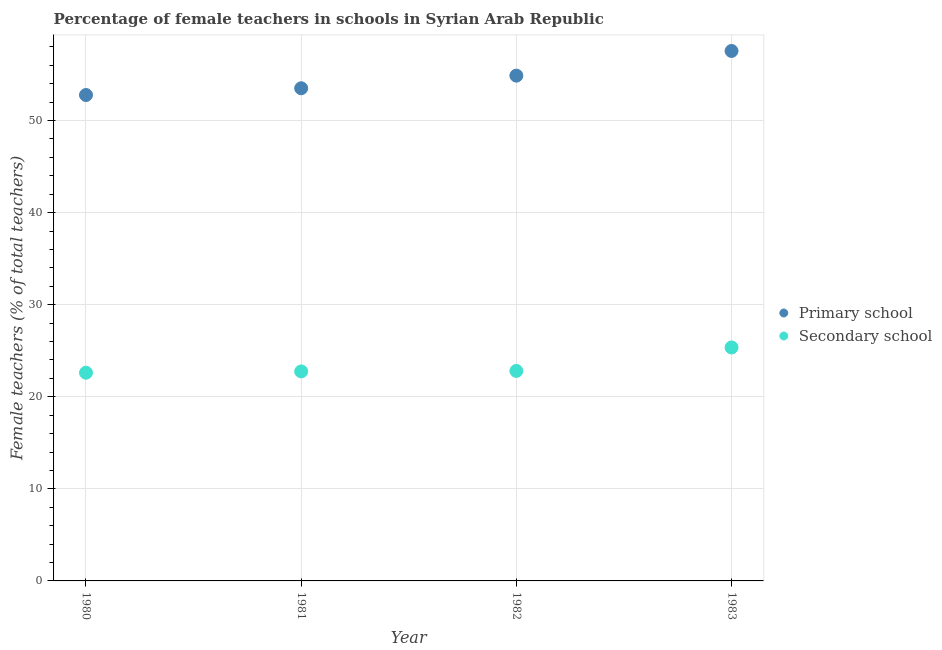How many different coloured dotlines are there?
Give a very brief answer. 2. Is the number of dotlines equal to the number of legend labels?
Offer a terse response. Yes. What is the percentage of female teachers in secondary schools in 1980?
Provide a short and direct response. 22.62. Across all years, what is the maximum percentage of female teachers in primary schools?
Offer a very short reply. 57.56. Across all years, what is the minimum percentage of female teachers in primary schools?
Provide a short and direct response. 52.78. What is the total percentage of female teachers in primary schools in the graph?
Keep it short and to the point. 218.73. What is the difference between the percentage of female teachers in secondary schools in 1981 and that in 1982?
Your answer should be very brief. -0.05. What is the difference between the percentage of female teachers in primary schools in 1982 and the percentage of female teachers in secondary schools in 1980?
Offer a terse response. 32.27. What is the average percentage of female teachers in primary schools per year?
Provide a short and direct response. 54.68. In the year 1980, what is the difference between the percentage of female teachers in primary schools and percentage of female teachers in secondary schools?
Your answer should be compact. 30.16. What is the ratio of the percentage of female teachers in secondary schools in 1980 to that in 1982?
Your answer should be very brief. 0.99. Is the percentage of female teachers in secondary schools in 1981 less than that in 1983?
Keep it short and to the point. Yes. Is the difference between the percentage of female teachers in primary schools in 1980 and 1981 greater than the difference between the percentage of female teachers in secondary schools in 1980 and 1981?
Your response must be concise. No. What is the difference between the highest and the second highest percentage of female teachers in primary schools?
Keep it short and to the point. 2.68. What is the difference between the highest and the lowest percentage of female teachers in secondary schools?
Your answer should be compact. 2.74. Is the sum of the percentage of female teachers in primary schools in 1981 and 1982 greater than the maximum percentage of female teachers in secondary schools across all years?
Offer a terse response. Yes. Does the percentage of female teachers in secondary schools monotonically increase over the years?
Your answer should be very brief. Yes. Is the percentage of female teachers in secondary schools strictly greater than the percentage of female teachers in primary schools over the years?
Keep it short and to the point. No. How many dotlines are there?
Give a very brief answer. 2. How many years are there in the graph?
Make the answer very short. 4. Does the graph contain any zero values?
Offer a terse response. No. How are the legend labels stacked?
Your response must be concise. Vertical. What is the title of the graph?
Make the answer very short. Percentage of female teachers in schools in Syrian Arab Republic. Does "Female labor force" appear as one of the legend labels in the graph?
Provide a succinct answer. No. What is the label or title of the X-axis?
Offer a terse response. Year. What is the label or title of the Y-axis?
Offer a very short reply. Female teachers (% of total teachers). What is the Female teachers (% of total teachers) in Primary school in 1980?
Provide a succinct answer. 52.78. What is the Female teachers (% of total teachers) of Secondary school in 1980?
Offer a terse response. 22.62. What is the Female teachers (% of total teachers) of Primary school in 1981?
Ensure brevity in your answer.  53.51. What is the Female teachers (% of total teachers) of Secondary school in 1981?
Offer a terse response. 22.76. What is the Female teachers (% of total teachers) of Primary school in 1982?
Provide a short and direct response. 54.88. What is the Female teachers (% of total teachers) of Secondary school in 1982?
Provide a succinct answer. 22.81. What is the Female teachers (% of total teachers) in Primary school in 1983?
Offer a terse response. 57.56. What is the Female teachers (% of total teachers) in Secondary school in 1983?
Provide a succinct answer. 25.36. Across all years, what is the maximum Female teachers (% of total teachers) of Primary school?
Keep it short and to the point. 57.56. Across all years, what is the maximum Female teachers (% of total teachers) of Secondary school?
Your answer should be compact. 25.36. Across all years, what is the minimum Female teachers (% of total teachers) of Primary school?
Ensure brevity in your answer.  52.78. Across all years, what is the minimum Female teachers (% of total teachers) of Secondary school?
Make the answer very short. 22.62. What is the total Female teachers (% of total teachers) of Primary school in the graph?
Ensure brevity in your answer.  218.73. What is the total Female teachers (% of total teachers) in Secondary school in the graph?
Give a very brief answer. 93.54. What is the difference between the Female teachers (% of total teachers) of Primary school in 1980 and that in 1981?
Provide a succinct answer. -0.73. What is the difference between the Female teachers (% of total teachers) of Secondary school in 1980 and that in 1981?
Make the answer very short. -0.14. What is the difference between the Female teachers (% of total teachers) in Primary school in 1980 and that in 1982?
Offer a very short reply. -2.1. What is the difference between the Female teachers (% of total teachers) of Secondary school in 1980 and that in 1982?
Give a very brief answer. -0.19. What is the difference between the Female teachers (% of total teachers) of Primary school in 1980 and that in 1983?
Your response must be concise. -4.78. What is the difference between the Female teachers (% of total teachers) of Secondary school in 1980 and that in 1983?
Ensure brevity in your answer.  -2.74. What is the difference between the Female teachers (% of total teachers) in Primary school in 1981 and that in 1982?
Give a very brief answer. -1.37. What is the difference between the Female teachers (% of total teachers) in Secondary school in 1981 and that in 1982?
Your response must be concise. -0.05. What is the difference between the Female teachers (% of total teachers) in Primary school in 1981 and that in 1983?
Offer a terse response. -4.05. What is the difference between the Female teachers (% of total teachers) in Secondary school in 1981 and that in 1983?
Give a very brief answer. -2.6. What is the difference between the Female teachers (% of total teachers) in Primary school in 1982 and that in 1983?
Make the answer very short. -2.68. What is the difference between the Female teachers (% of total teachers) in Secondary school in 1982 and that in 1983?
Your response must be concise. -2.55. What is the difference between the Female teachers (% of total teachers) in Primary school in 1980 and the Female teachers (% of total teachers) in Secondary school in 1981?
Your answer should be very brief. 30.02. What is the difference between the Female teachers (% of total teachers) of Primary school in 1980 and the Female teachers (% of total teachers) of Secondary school in 1982?
Your response must be concise. 29.97. What is the difference between the Female teachers (% of total teachers) in Primary school in 1980 and the Female teachers (% of total teachers) in Secondary school in 1983?
Your answer should be very brief. 27.42. What is the difference between the Female teachers (% of total teachers) of Primary school in 1981 and the Female teachers (% of total teachers) of Secondary school in 1982?
Keep it short and to the point. 30.7. What is the difference between the Female teachers (% of total teachers) of Primary school in 1981 and the Female teachers (% of total teachers) of Secondary school in 1983?
Make the answer very short. 28.15. What is the difference between the Female teachers (% of total teachers) in Primary school in 1982 and the Female teachers (% of total teachers) in Secondary school in 1983?
Make the answer very short. 29.52. What is the average Female teachers (% of total teachers) in Primary school per year?
Your response must be concise. 54.68. What is the average Female teachers (% of total teachers) in Secondary school per year?
Give a very brief answer. 23.38. In the year 1980, what is the difference between the Female teachers (% of total teachers) of Primary school and Female teachers (% of total teachers) of Secondary school?
Make the answer very short. 30.16. In the year 1981, what is the difference between the Female teachers (% of total teachers) in Primary school and Female teachers (% of total teachers) in Secondary school?
Your response must be concise. 30.75. In the year 1982, what is the difference between the Female teachers (% of total teachers) of Primary school and Female teachers (% of total teachers) of Secondary school?
Ensure brevity in your answer.  32.07. In the year 1983, what is the difference between the Female teachers (% of total teachers) of Primary school and Female teachers (% of total teachers) of Secondary school?
Your answer should be compact. 32.2. What is the ratio of the Female teachers (% of total teachers) in Primary school in 1980 to that in 1981?
Offer a terse response. 0.99. What is the ratio of the Female teachers (% of total teachers) of Primary school in 1980 to that in 1982?
Give a very brief answer. 0.96. What is the ratio of the Female teachers (% of total teachers) of Primary school in 1980 to that in 1983?
Provide a succinct answer. 0.92. What is the ratio of the Female teachers (% of total teachers) of Secondary school in 1980 to that in 1983?
Offer a very short reply. 0.89. What is the ratio of the Female teachers (% of total teachers) of Primary school in 1981 to that in 1982?
Your response must be concise. 0.97. What is the ratio of the Female teachers (% of total teachers) of Primary school in 1981 to that in 1983?
Your response must be concise. 0.93. What is the ratio of the Female teachers (% of total teachers) of Secondary school in 1981 to that in 1983?
Offer a terse response. 0.9. What is the ratio of the Female teachers (% of total teachers) in Primary school in 1982 to that in 1983?
Offer a very short reply. 0.95. What is the ratio of the Female teachers (% of total teachers) in Secondary school in 1982 to that in 1983?
Make the answer very short. 0.9. What is the difference between the highest and the second highest Female teachers (% of total teachers) in Primary school?
Offer a terse response. 2.68. What is the difference between the highest and the second highest Female teachers (% of total teachers) in Secondary school?
Offer a terse response. 2.55. What is the difference between the highest and the lowest Female teachers (% of total teachers) of Primary school?
Keep it short and to the point. 4.78. What is the difference between the highest and the lowest Female teachers (% of total teachers) in Secondary school?
Offer a terse response. 2.74. 